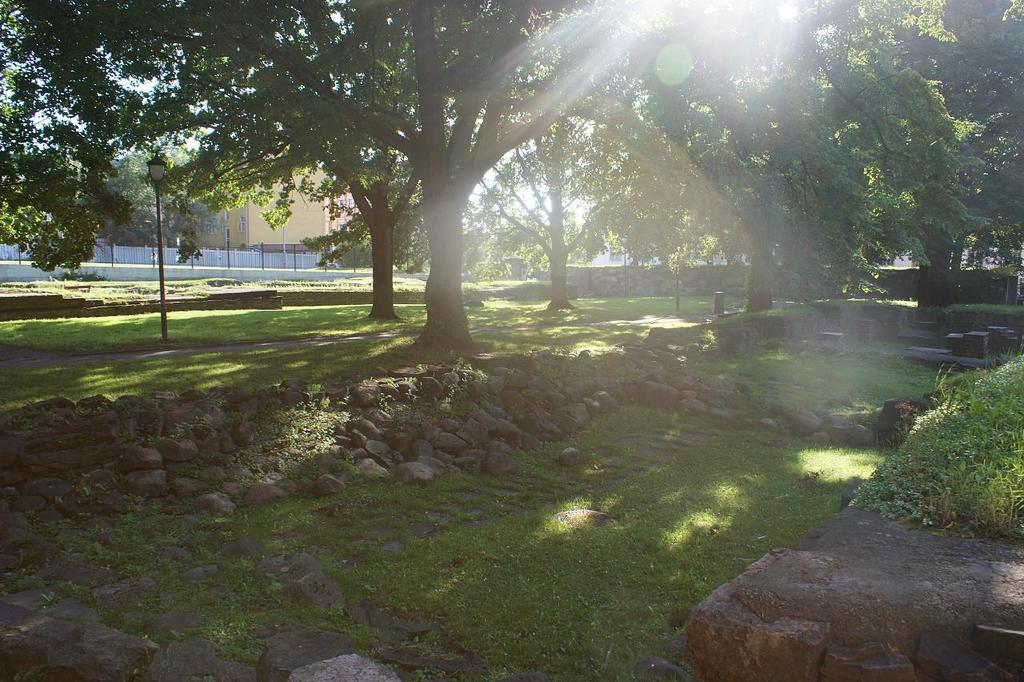What type of ground surface is visible in the image? There is grass and stones on the ground in the image. What can be seen in the background of the image? In the background, there are poles, trees, plants, a wall, a building, windows, and the sky visible. How many different types of structures are visible in the background? There are two types of structures visible in the background: a wall and a building. What is the natural environment visible in the image? The natural environment includes grass, stones, trees, and plants. How does the wax turn and stretch in the image? There is no wax present in the image, so this question cannot be answered. 